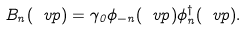Convert formula to latex. <formula><loc_0><loc_0><loc_500><loc_500>B _ { n } ( { \ v p } ) = \gamma _ { 0 } \phi _ { - n } ( { \ v p } ) \phi _ { n } ^ { \dagger } ( { \ v p } ) .</formula> 